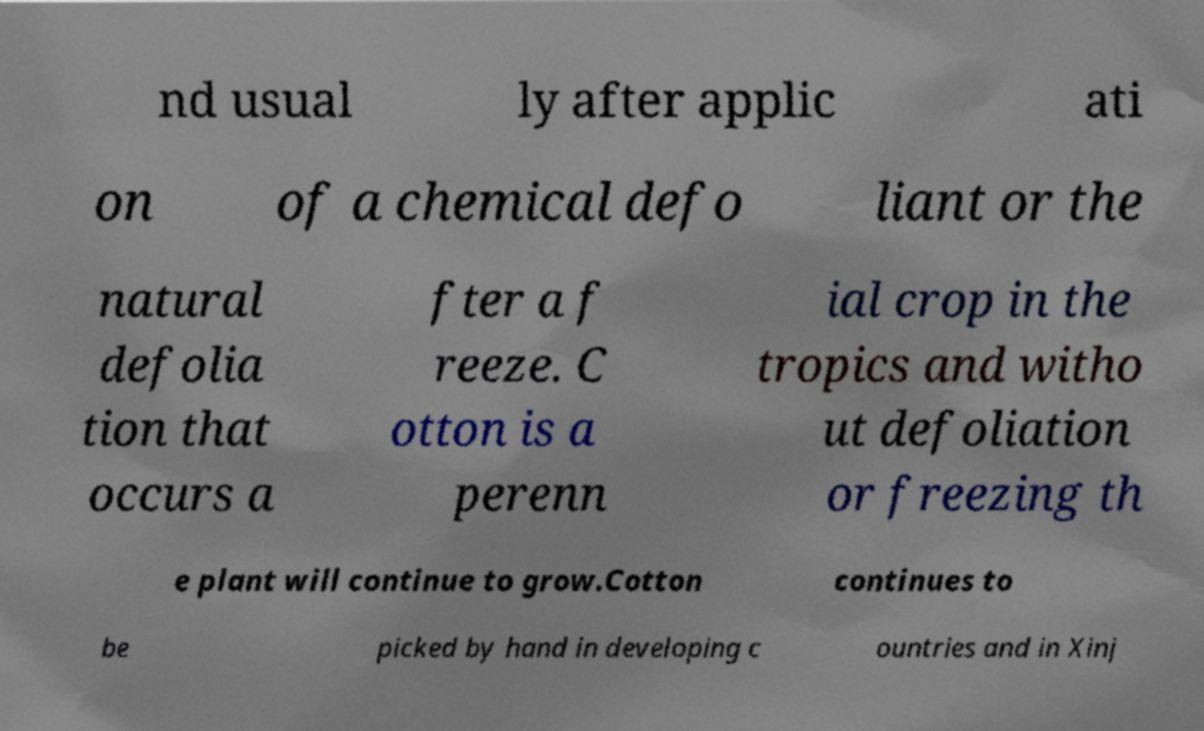Please read and relay the text visible in this image. What does it say? nd usual ly after applic ati on of a chemical defo liant or the natural defolia tion that occurs a fter a f reeze. C otton is a perenn ial crop in the tropics and witho ut defoliation or freezing th e plant will continue to grow.Cotton continues to be picked by hand in developing c ountries and in Xinj 